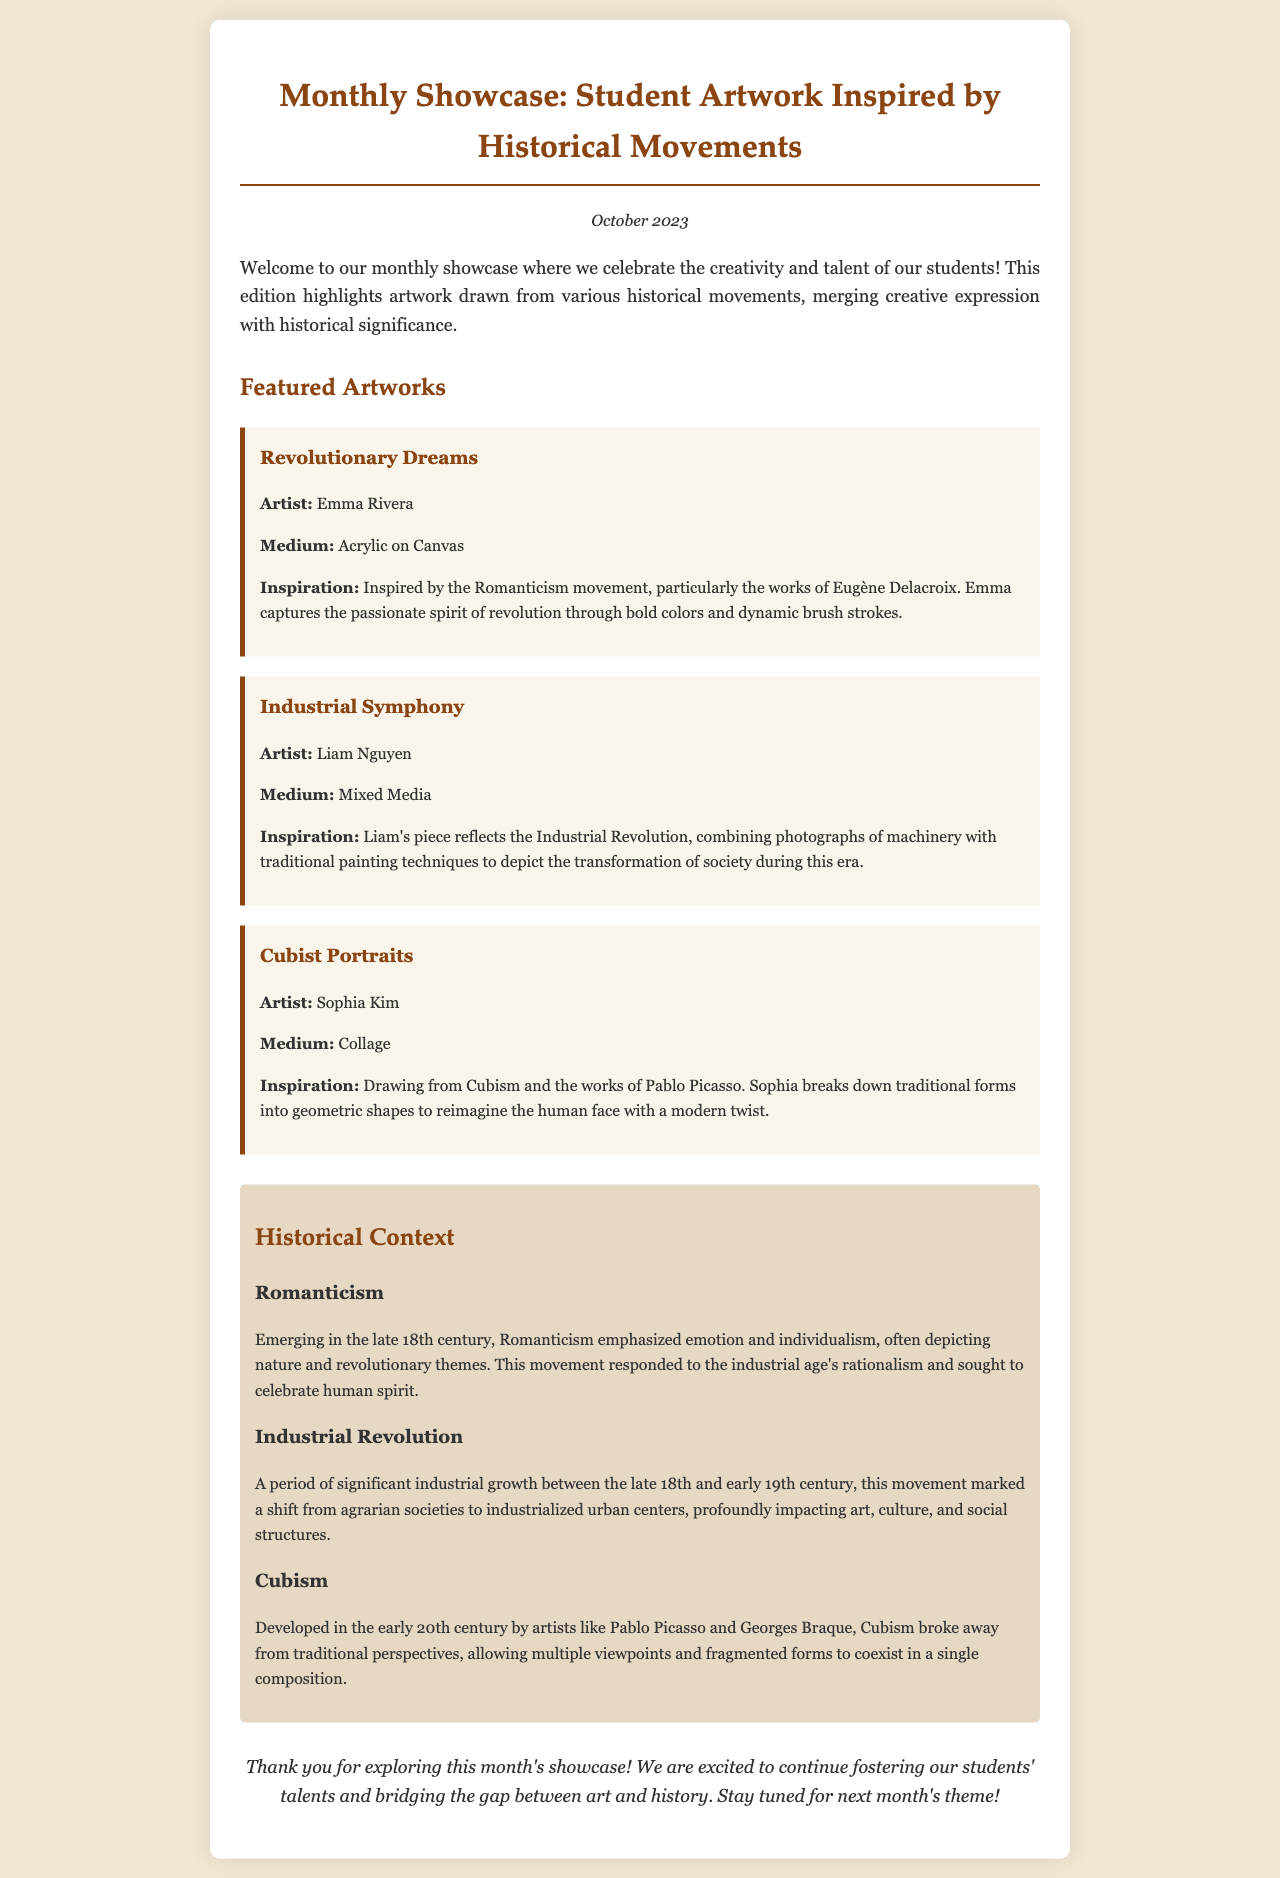What is the title of the showcase? The title of the showcase is mentioned at the top of the document, highlighting the theme of student artwork.
Answer: Monthly Showcase: Student Artwork Inspired by Historical Movements Who is the artist of "Revolutionary Dreams"? The artist is identified within the artwork description section for "Revolutionary Dreams."
Answer: Emma Rivera What medium is used for the artwork "Cubist Portraits"? The medium is specified in the description of "Cubist Portraits."
Answer: Collage In what month was this newsletter published? The month is stated clearly in the date section of the document.
Answer: October 2023 What historical movement inspired "Industrial Symphony"? The inspiration is provided in the description of the artwork "Industrial Symphony."
Answer: Industrial Revolution Which artistic movement emphasizes emotion and individualism? The document discusses this movement in the historical context section.
Answer: Romanticism How many artworks are featured in the showcase? The total number of artworks is found by counting the individual pieces described in the document.
Answer: Three What color is the background of the newsletter? The background color of the body is specified in the style section of the code.
Answer: #f0e6d2 What is the closing remark intended to convey? The closing remark summarizes the purpose of the showcase and expresses gratitude.
Answer: Thank you for exploring this month's showcase! 